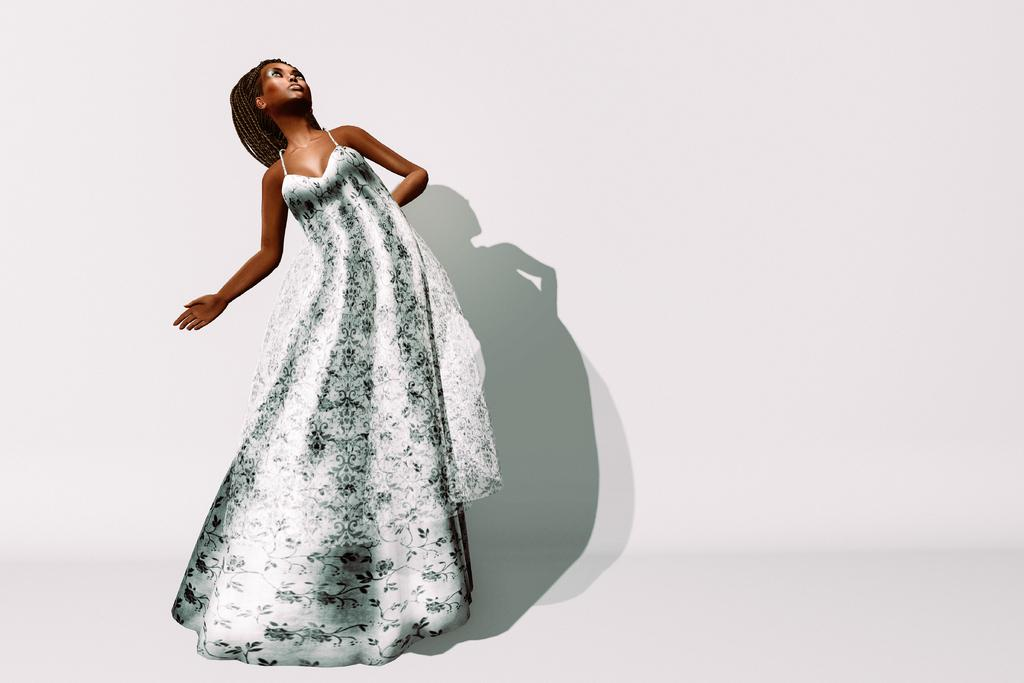Who is the main subject in the image? There is a woman in the image. What is the woman doing in the image? The woman is standing. What can be seen in the background of the image? There is a shadow on the wall in the background of the image. What type of friction can be observed between the woman and the calendar in the image? There is no calendar present in the image, and therefore no friction can be observed between the woman and a calendar. 